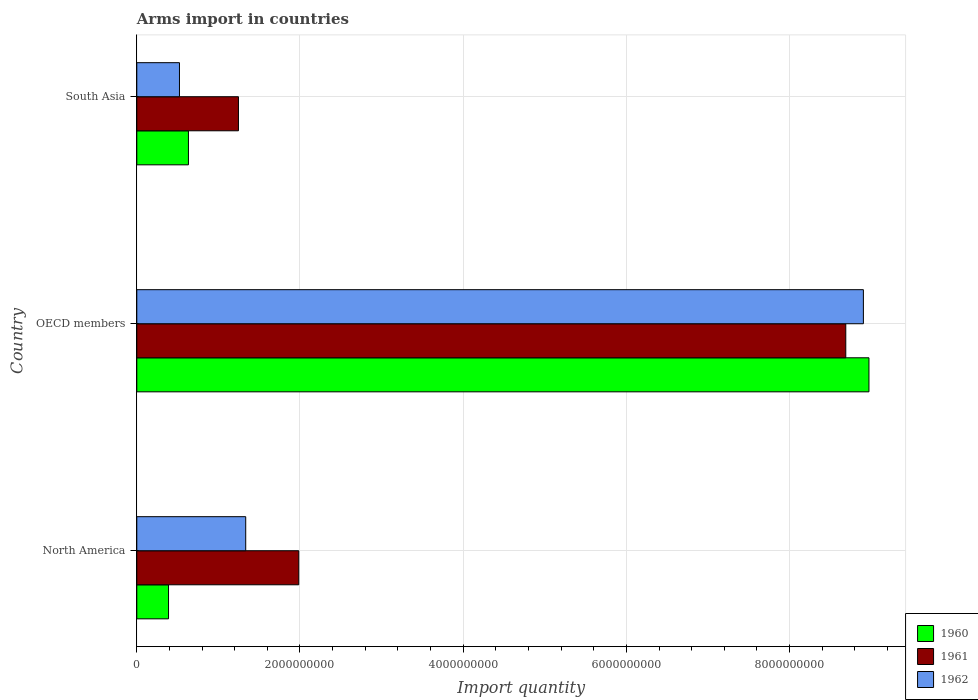How many different coloured bars are there?
Your response must be concise. 3. How many bars are there on the 3rd tick from the bottom?
Keep it short and to the point. 3. What is the label of the 3rd group of bars from the top?
Ensure brevity in your answer.  North America. In how many cases, is the number of bars for a given country not equal to the number of legend labels?
Provide a short and direct response. 0. What is the total arms import in 1962 in OECD members?
Ensure brevity in your answer.  8.90e+09. Across all countries, what is the maximum total arms import in 1961?
Provide a short and direct response. 8.69e+09. Across all countries, what is the minimum total arms import in 1960?
Offer a terse response. 3.89e+08. In which country was the total arms import in 1962 maximum?
Your answer should be compact. OECD members. What is the total total arms import in 1961 in the graph?
Ensure brevity in your answer.  1.19e+1. What is the difference between the total arms import in 1960 in North America and that in OECD members?
Offer a very short reply. -8.58e+09. What is the difference between the total arms import in 1960 in North America and the total arms import in 1961 in South Asia?
Ensure brevity in your answer.  -8.57e+08. What is the average total arms import in 1961 per country?
Your answer should be very brief. 3.97e+09. What is the difference between the total arms import in 1961 and total arms import in 1962 in OECD members?
Provide a succinct answer. -2.16e+08. In how many countries, is the total arms import in 1960 greater than 8000000000 ?
Offer a very short reply. 1. What is the ratio of the total arms import in 1962 in OECD members to that in South Asia?
Provide a short and direct response. 17.03. What is the difference between the highest and the second highest total arms import in 1961?
Give a very brief answer. 6.70e+09. What is the difference between the highest and the lowest total arms import in 1961?
Provide a short and direct response. 7.44e+09. What does the 1st bar from the top in South Asia represents?
Make the answer very short. 1962. Are all the bars in the graph horizontal?
Make the answer very short. Yes. How many countries are there in the graph?
Provide a short and direct response. 3. What is the difference between two consecutive major ticks on the X-axis?
Keep it short and to the point. 2.00e+09. Are the values on the major ticks of X-axis written in scientific E-notation?
Provide a short and direct response. No. Where does the legend appear in the graph?
Your response must be concise. Bottom right. What is the title of the graph?
Give a very brief answer. Arms import in countries. What is the label or title of the X-axis?
Provide a succinct answer. Import quantity. What is the Import quantity in 1960 in North America?
Make the answer very short. 3.89e+08. What is the Import quantity of 1961 in North America?
Your answer should be compact. 1.98e+09. What is the Import quantity of 1962 in North America?
Ensure brevity in your answer.  1.34e+09. What is the Import quantity in 1960 in OECD members?
Provide a short and direct response. 8.97e+09. What is the Import quantity of 1961 in OECD members?
Your answer should be compact. 8.69e+09. What is the Import quantity in 1962 in OECD members?
Give a very brief answer. 8.90e+09. What is the Import quantity of 1960 in South Asia?
Give a very brief answer. 6.33e+08. What is the Import quantity of 1961 in South Asia?
Your answer should be very brief. 1.25e+09. What is the Import quantity in 1962 in South Asia?
Give a very brief answer. 5.23e+08. Across all countries, what is the maximum Import quantity in 1960?
Offer a very short reply. 8.97e+09. Across all countries, what is the maximum Import quantity in 1961?
Your answer should be compact. 8.69e+09. Across all countries, what is the maximum Import quantity of 1962?
Your answer should be compact. 8.90e+09. Across all countries, what is the minimum Import quantity in 1960?
Your answer should be very brief. 3.89e+08. Across all countries, what is the minimum Import quantity in 1961?
Offer a terse response. 1.25e+09. Across all countries, what is the minimum Import quantity of 1962?
Keep it short and to the point. 5.23e+08. What is the total Import quantity of 1960 in the graph?
Offer a very short reply. 1.00e+1. What is the total Import quantity of 1961 in the graph?
Your answer should be very brief. 1.19e+1. What is the total Import quantity of 1962 in the graph?
Your answer should be compact. 1.08e+1. What is the difference between the Import quantity of 1960 in North America and that in OECD members?
Make the answer very short. -8.58e+09. What is the difference between the Import quantity in 1961 in North America and that in OECD members?
Provide a short and direct response. -6.70e+09. What is the difference between the Import quantity in 1962 in North America and that in OECD members?
Provide a short and direct response. -7.57e+09. What is the difference between the Import quantity of 1960 in North America and that in South Asia?
Offer a terse response. -2.44e+08. What is the difference between the Import quantity of 1961 in North America and that in South Asia?
Your answer should be very brief. 7.39e+08. What is the difference between the Import quantity in 1962 in North America and that in South Asia?
Offer a very short reply. 8.12e+08. What is the difference between the Import quantity of 1960 in OECD members and that in South Asia?
Offer a terse response. 8.34e+09. What is the difference between the Import quantity in 1961 in OECD members and that in South Asia?
Offer a terse response. 7.44e+09. What is the difference between the Import quantity in 1962 in OECD members and that in South Asia?
Your answer should be very brief. 8.38e+09. What is the difference between the Import quantity in 1960 in North America and the Import quantity in 1961 in OECD members?
Give a very brief answer. -8.30e+09. What is the difference between the Import quantity in 1960 in North America and the Import quantity in 1962 in OECD members?
Your response must be concise. -8.52e+09. What is the difference between the Import quantity of 1961 in North America and the Import quantity of 1962 in OECD members?
Keep it short and to the point. -6.92e+09. What is the difference between the Import quantity in 1960 in North America and the Import quantity in 1961 in South Asia?
Offer a terse response. -8.57e+08. What is the difference between the Import quantity of 1960 in North America and the Import quantity of 1962 in South Asia?
Your response must be concise. -1.34e+08. What is the difference between the Import quantity in 1961 in North America and the Import quantity in 1962 in South Asia?
Ensure brevity in your answer.  1.46e+09. What is the difference between the Import quantity in 1960 in OECD members and the Import quantity in 1961 in South Asia?
Your answer should be very brief. 7.73e+09. What is the difference between the Import quantity in 1960 in OECD members and the Import quantity in 1962 in South Asia?
Your answer should be very brief. 8.45e+09. What is the difference between the Import quantity in 1961 in OECD members and the Import quantity in 1962 in South Asia?
Offer a terse response. 8.17e+09. What is the average Import quantity of 1960 per country?
Ensure brevity in your answer.  3.33e+09. What is the average Import quantity of 1961 per country?
Offer a terse response. 3.97e+09. What is the average Import quantity in 1962 per country?
Provide a short and direct response. 3.59e+09. What is the difference between the Import quantity in 1960 and Import quantity in 1961 in North America?
Make the answer very short. -1.60e+09. What is the difference between the Import quantity in 1960 and Import quantity in 1962 in North America?
Offer a terse response. -9.46e+08. What is the difference between the Import quantity of 1961 and Import quantity of 1962 in North America?
Provide a short and direct response. 6.50e+08. What is the difference between the Import quantity in 1960 and Import quantity in 1961 in OECD members?
Keep it short and to the point. 2.84e+08. What is the difference between the Import quantity of 1960 and Import quantity of 1962 in OECD members?
Offer a terse response. 6.80e+07. What is the difference between the Import quantity in 1961 and Import quantity in 1962 in OECD members?
Your response must be concise. -2.16e+08. What is the difference between the Import quantity of 1960 and Import quantity of 1961 in South Asia?
Your response must be concise. -6.13e+08. What is the difference between the Import quantity of 1960 and Import quantity of 1962 in South Asia?
Your response must be concise. 1.10e+08. What is the difference between the Import quantity in 1961 and Import quantity in 1962 in South Asia?
Offer a very short reply. 7.23e+08. What is the ratio of the Import quantity in 1960 in North America to that in OECD members?
Give a very brief answer. 0.04. What is the ratio of the Import quantity of 1961 in North America to that in OECD members?
Ensure brevity in your answer.  0.23. What is the ratio of the Import quantity of 1962 in North America to that in OECD members?
Give a very brief answer. 0.15. What is the ratio of the Import quantity of 1960 in North America to that in South Asia?
Your answer should be very brief. 0.61. What is the ratio of the Import quantity in 1961 in North America to that in South Asia?
Give a very brief answer. 1.59. What is the ratio of the Import quantity of 1962 in North America to that in South Asia?
Your answer should be very brief. 2.55. What is the ratio of the Import quantity of 1960 in OECD members to that in South Asia?
Provide a short and direct response. 14.18. What is the ratio of the Import quantity in 1961 in OECD members to that in South Asia?
Provide a succinct answer. 6.97. What is the ratio of the Import quantity of 1962 in OECD members to that in South Asia?
Ensure brevity in your answer.  17.03. What is the difference between the highest and the second highest Import quantity in 1960?
Provide a short and direct response. 8.34e+09. What is the difference between the highest and the second highest Import quantity in 1961?
Make the answer very short. 6.70e+09. What is the difference between the highest and the second highest Import quantity of 1962?
Provide a succinct answer. 7.57e+09. What is the difference between the highest and the lowest Import quantity in 1960?
Your answer should be compact. 8.58e+09. What is the difference between the highest and the lowest Import quantity in 1961?
Provide a succinct answer. 7.44e+09. What is the difference between the highest and the lowest Import quantity of 1962?
Provide a short and direct response. 8.38e+09. 